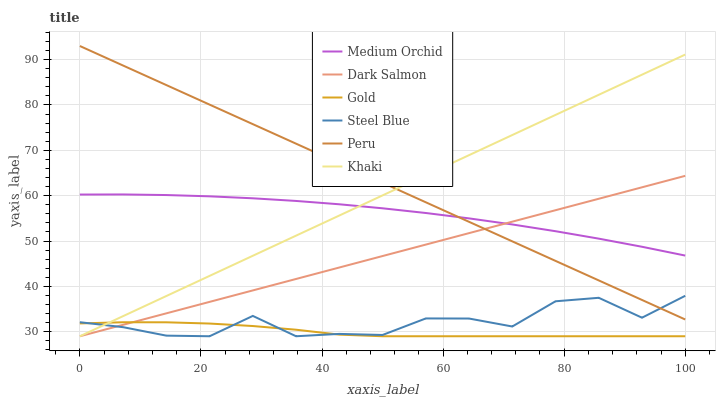Does Gold have the minimum area under the curve?
Answer yes or no. Yes. Does Peru have the maximum area under the curve?
Answer yes or no. Yes. Does Medium Orchid have the minimum area under the curve?
Answer yes or no. No. Does Medium Orchid have the maximum area under the curve?
Answer yes or no. No. Is Dark Salmon the smoothest?
Answer yes or no. Yes. Is Steel Blue the roughest?
Answer yes or no. Yes. Is Gold the smoothest?
Answer yes or no. No. Is Gold the roughest?
Answer yes or no. No. Does Khaki have the lowest value?
Answer yes or no. Yes. Does Medium Orchid have the lowest value?
Answer yes or no. No. Does Peru have the highest value?
Answer yes or no. Yes. Does Medium Orchid have the highest value?
Answer yes or no. No. Is Steel Blue less than Medium Orchid?
Answer yes or no. Yes. Is Medium Orchid greater than Gold?
Answer yes or no. Yes. Does Dark Salmon intersect Khaki?
Answer yes or no. Yes. Is Dark Salmon less than Khaki?
Answer yes or no. No. Is Dark Salmon greater than Khaki?
Answer yes or no. No. Does Steel Blue intersect Medium Orchid?
Answer yes or no. No. 